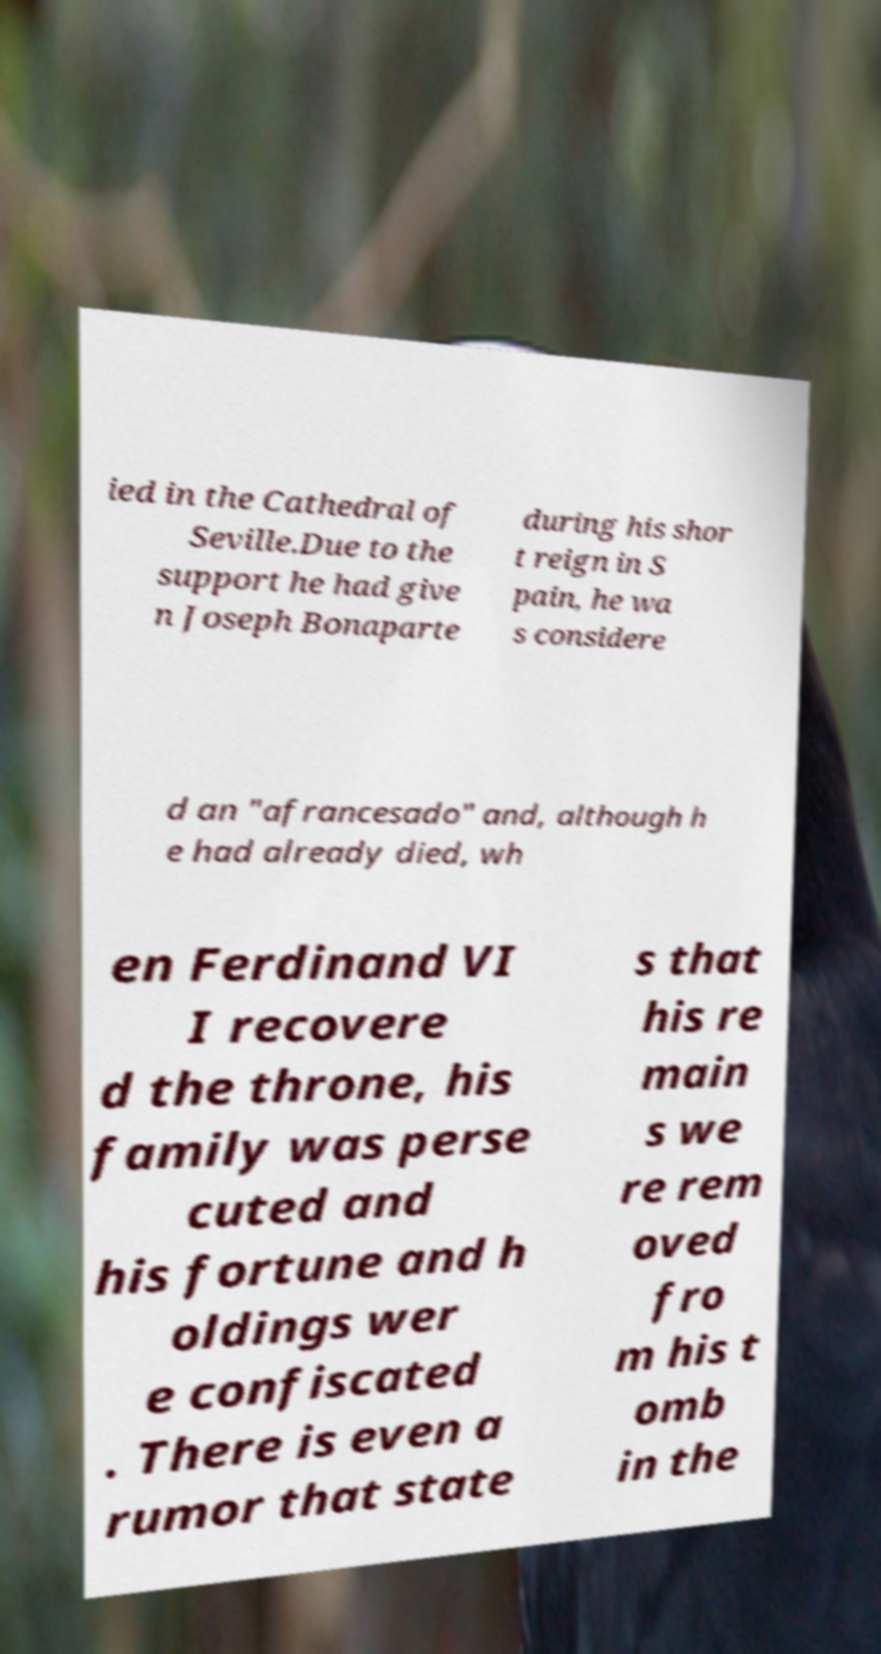What messages or text are displayed in this image? I need them in a readable, typed format. ied in the Cathedral of Seville.Due to the support he had give n Joseph Bonaparte during his shor t reign in S pain, he wa s considere d an "afrancesado" and, although h e had already died, wh en Ferdinand VI I recovere d the throne, his family was perse cuted and his fortune and h oldings wer e confiscated . There is even a rumor that state s that his re main s we re rem oved fro m his t omb in the 